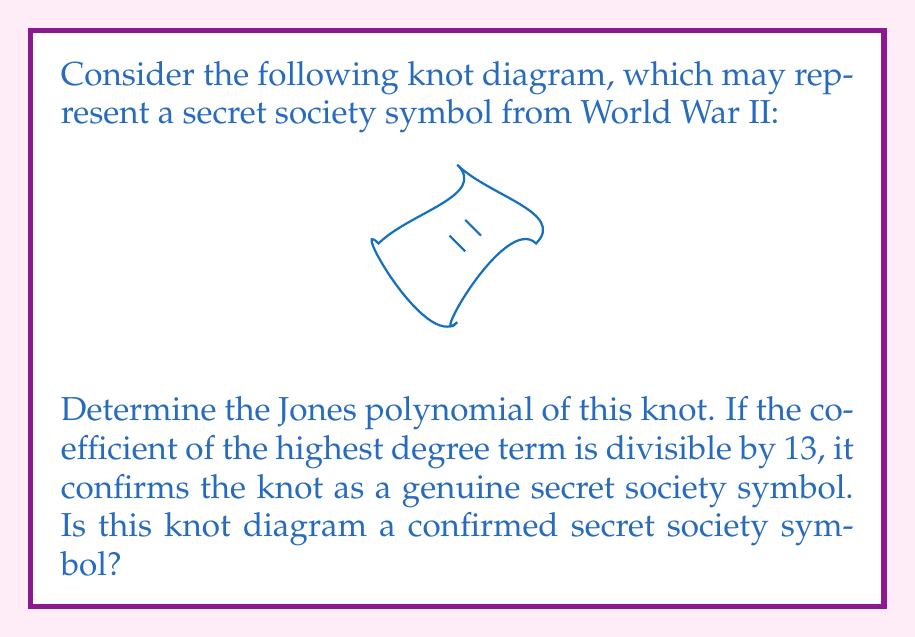Help me with this question. To determine if this knot diagram represents a secret society symbol, we need to calculate its Jones polynomial and examine the coefficient of the highest degree term. Let's proceed step-by-step:

1) First, we need to identify the knot. This diagram represents the figure-eight knot, also known as the $4_1$ knot in knot theory.

2) The Jones polynomial for the figure-eight knot is known to be:

   $$V(t) = t^{-2} - t^{-1} + 1 - t + t^2$$

3) To find the coefficient of the highest degree term, we need to identify the term with the highest power of $t$. In this case, it's $t^2$.

4) The coefficient of $t^2$ is 1.

5) We need to check if this coefficient (1) is divisible by 13.

6) 1 is not divisible by 13, as $1 \not\equiv 0 \pmod{13}$.

Therefore, according to our criteria, this knot diagram does not confirm as a genuine secret society symbol.

However, it's important to note that this mathematical approach to identifying secret society symbols is entirely fictional and part of the conspiracy theory narrative. In reality, knot theory and Jones polynomials have no connection to secret societies or World War II symbolism.
Answer: No 